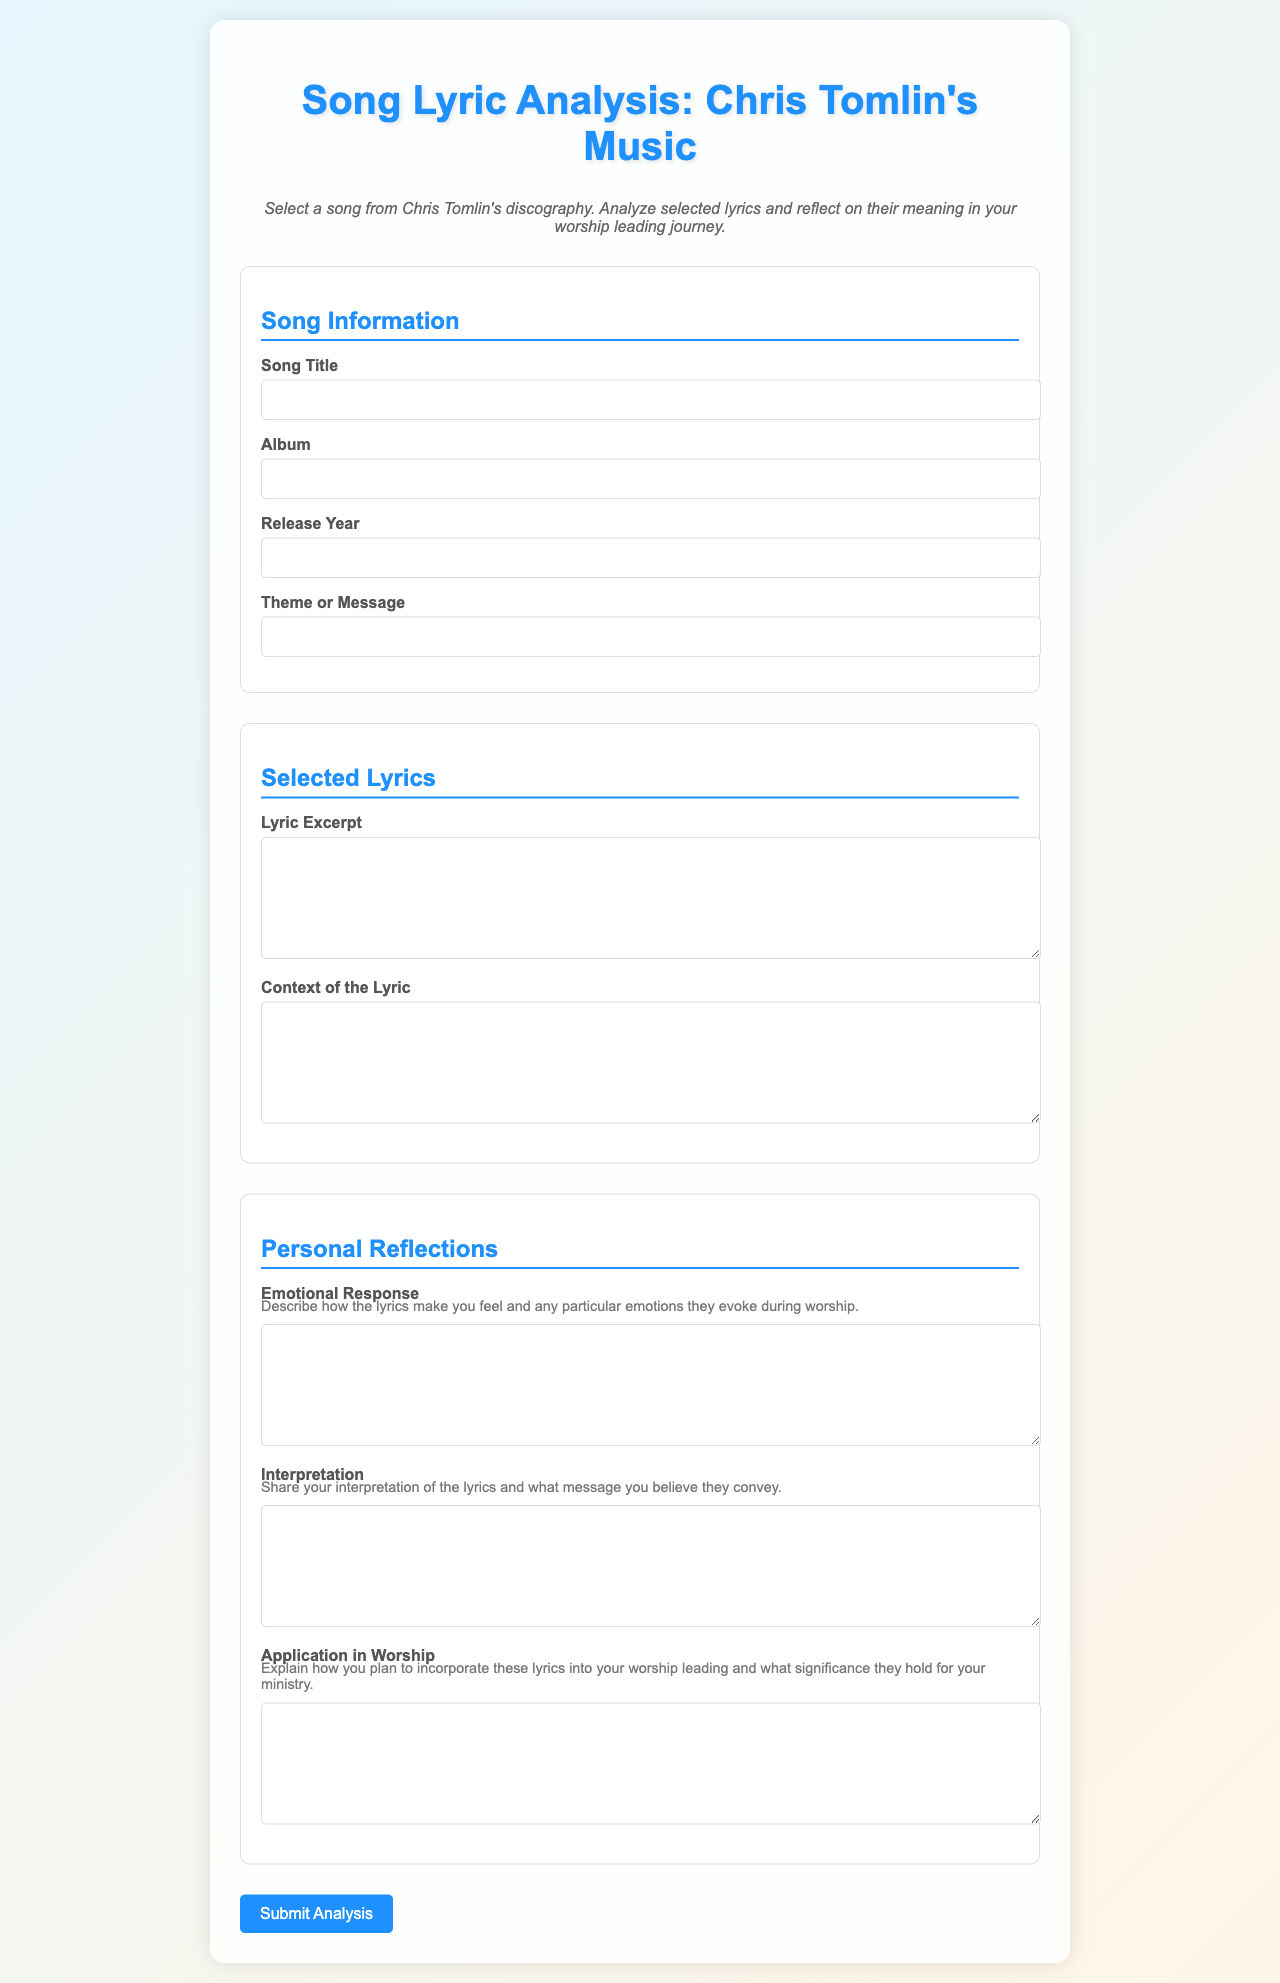what is the title of the document? The title of the document is prominently displayed at the top of the rendered HTML, indicating its purpose and content.
Answer: Song Lyric Analysis: Chris Tomlin's Music what should you select before analyzing the lyrics? The instructions specify a selection process prior to engaging in the analysis of the lyrics.
Answer: a song what type of response is requested for the "Emotional Response" section? This section asks for a description related to feelings and emotions experienced through the lyrics, indicating a focus on personal reflection.
Answer: Describe how the lyrics make you feel how many sections are there in the form? By counting the main divisions in the form, we can determine the number of distinct sections.
Answer: three which color is used for the main title? The title utilizes a specific color that enhances its visibility and attractiveness within the document's design.
Answer: #1e90ff what type of input is required for the "Lyric Excerpt" field? The field requires a specific type of text input which is suitable for presenting longer pieces of content.
Answer: textarea how is the background of the document described? The background is characterized by a particular design choice that creates visual appeal and atmosphere for the reader.
Answer: linear gradient what does the "Application in Worship" section focus on? This section specifically directs the respondent to elaborate on their intended use of the lyrics within a particular context.
Answer: Incorporate these lyrics into your worship leading what visual element separates the title of each section? The document employs a specific design feature that helps organize and visually distinguish the various segments.
Answer: Border what is the color of the button used to submit the analysis? The button for submitting the analysis uses a distinctive color that stands out within the document's layout.
Answer: #1e90ff 